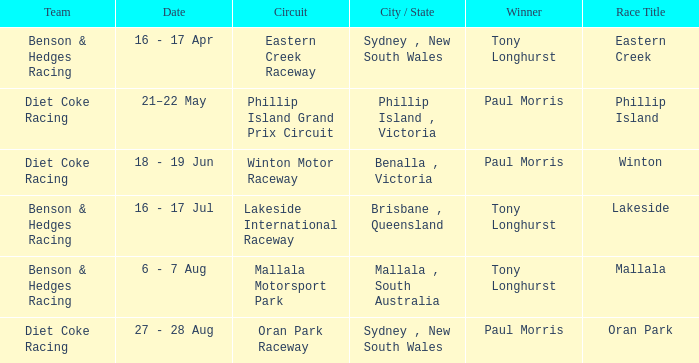Which driver won the Phillip Island Grand Prix Circuit? Paul Morris. 